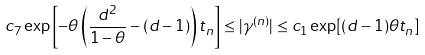Convert formula to latex. <formula><loc_0><loc_0><loc_500><loc_500>c _ { 7 } \exp \left [ - \theta \left ( \frac { d ^ { 2 } } { 1 - \theta } - ( d - 1 ) \right ) t _ { n } \right ] \leq | \gamma ^ { ( n ) } | \leq c _ { 1 } \exp [ ( d - 1 ) \theta t _ { n } ]</formula> 